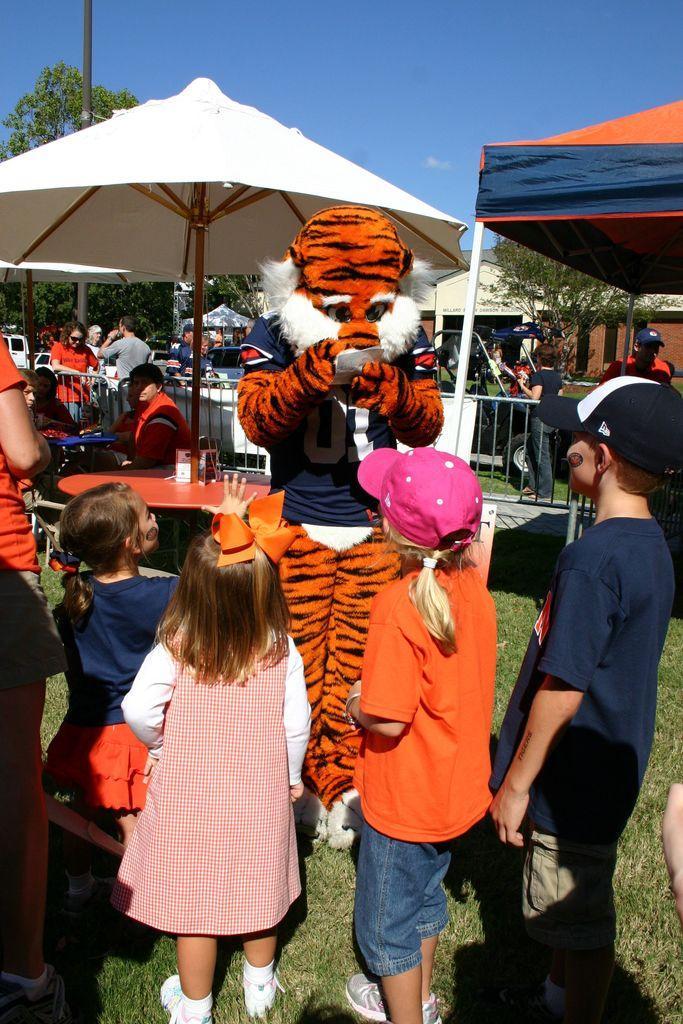Can you describe this image briefly? In this image we can see persons wearing costumes, children standing on the ground, persons sitting on the chairs, parasols, grills, tent, trees, buildings and sky with clouds. 